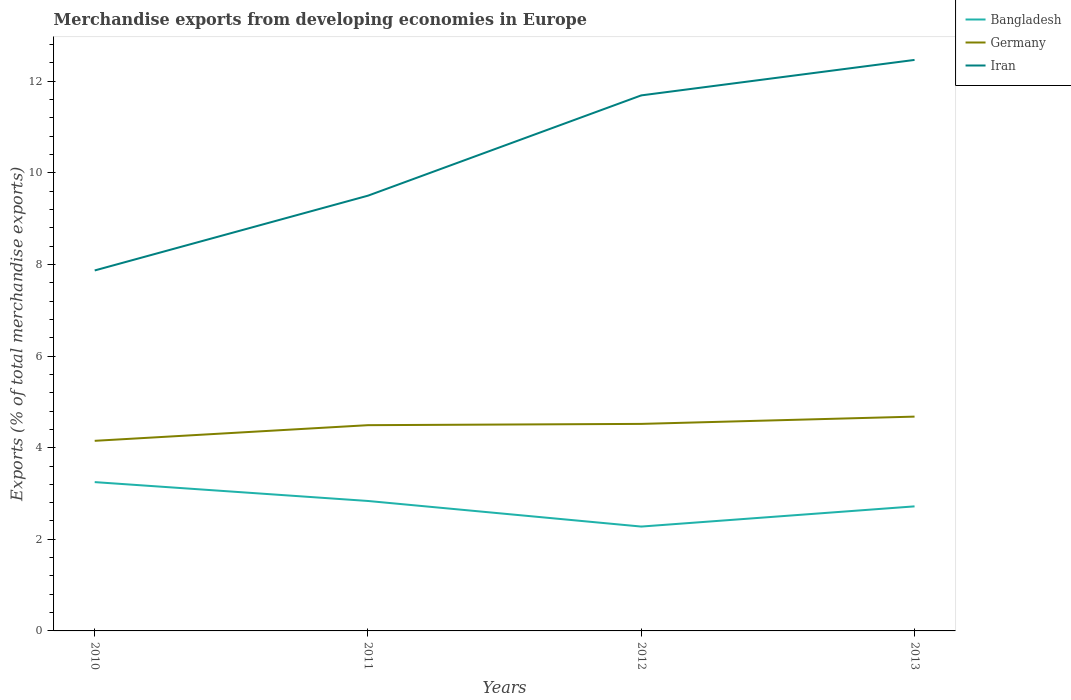Does the line corresponding to Iran intersect with the line corresponding to Bangladesh?
Offer a very short reply. No. Is the number of lines equal to the number of legend labels?
Offer a very short reply. Yes. Across all years, what is the maximum percentage of total merchandise exports in Germany?
Your answer should be compact. 4.15. In which year was the percentage of total merchandise exports in Bangladesh maximum?
Give a very brief answer. 2012. What is the total percentage of total merchandise exports in Iran in the graph?
Your answer should be compact. -0.77. What is the difference between the highest and the second highest percentage of total merchandise exports in Iran?
Give a very brief answer. 4.6. What is the difference between the highest and the lowest percentage of total merchandise exports in Bangladesh?
Provide a succinct answer. 2. Is the percentage of total merchandise exports in Bangladesh strictly greater than the percentage of total merchandise exports in Iran over the years?
Ensure brevity in your answer.  Yes. How many lines are there?
Offer a very short reply. 3. Does the graph contain any zero values?
Provide a succinct answer. No. Where does the legend appear in the graph?
Your answer should be compact. Top right. How many legend labels are there?
Provide a short and direct response. 3. What is the title of the graph?
Your answer should be very brief. Merchandise exports from developing economies in Europe. What is the label or title of the X-axis?
Give a very brief answer. Years. What is the label or title of the Y-axis?
Your response must be concise. Exports (% of total merchandise exports). What is the Exports (% of total merchandise exports) of Bangladesh in 2010?
Make the answer very short. 3.25. What is the Exports (% of total merchandise exports) of Germany in 2010?
Ensure brevity in your answer.  4.15. What is the Exports (% of total merchandise exports) of Iran in 2010?
Your answer should be compact. 7.87. What is the Exports (% of total merchandise exports) of Bangladesh in 2011?
Ensure brevity in your answer.  2.84. What is the Exports (% of total merchandise exports) of Germany in 2011?
Offer a terse response. 4.49. What is the Exports (% of total merchandise exports) of Iran in 2011?
Provide a succinct answer. 9.5. What is the Exports (% of total merchandise exports) of Bangladesh in 2012?
Offer a terse response. 2.28. What is the Exports (% of total merchandise exports) of Germany in 2012?
Offer a very short reply. 4.52. What is the Exports (% of total merchandise exports) in Iran in 2012?
Offer a very short reply. 11.69. What is the Exports (% of total merchandise exports) in Bangladesh in 2013?
Keep it short and to the point. 2.72. What is the Exports (% of total merchandise exports) in Germany in 2013?
Your answer should be compact. 4.68. What is the Exports (% of total merchandise exports) of Iran in 2013?
Provide a succinct answer. 12.47. Across all years, what is the maximum Exports (% of total merchandise exports) of Bangladesh?
Ensure brevity in your answer.  3.25. Across all years, what is the maximum Exports (% of total merchandise exports) of Germany?
Provide a succinct answer. 4.68. Across all years, what is the maximum Exports (% of total merchandise exports) of Iran?
Provide a succinct answer. 12.47. Across all years, what is the minimum Exports (% of total merchandise exports) in Bangladesh?
Provide a succinct answer. 2.28. Across all years, what is the minimum Exports (% of total merchandise exports) in Germany?
Keep it short and to the point. 4.15. Across all years, what is the minimum Exports (% of total merchandise exports) in Iran?
Provide a short and direct response. 7.87. What is the total Exports (% of total merchandise exports) in Bangladesh in the graph?
Make the answer very short. 11.08. What is the total Exports (% of total merchandise exports) of Germany in the graph?
Ensure brevity in your answer.  17.84. What is the total Exports (% of total merchandise exports) of Iran in the graph?
Your answer should be very brief. 41.53. What is the difference between the Exports (% of total merchandise exports) of Bangladesh in 2010 and that in 2011?
Your response must be concise. 0.41. What is the difference between the Exports (% of total merchandise exports) of Germany in 2010 and that in 2011?
Ensure brevity in your answer.  -0.34. What is the difference between the Exports (% of total merchandise exports) in Iran in 2010 and that in 2011?
Offer a terse response. -1.63. What is the difference between the Exports (% of total merchandise exports) of Bangladesh in 2010 and that in 2012?
Keep it short and to the point. 0.97. What is the difference between the Exports (% of total merchandise exports) of Germany in 2010 and that in 2012?
Provide a succinct answer. -0.37. What is the difference between the Exports (% of total merchandise exports) of Iran in 2010 and that in 2012?
Provide a short and direct response. -3.82. What is the difference between the Exports (% of total merchandise exports) in Bangladesh in 2010 and that in 2013?
Your response must be concise. 0.53. What is the difference between the Exports (% of total merchandise exports) of Germany in 2010 and that in 2013?
Your answer should be very brief. -0.53. What is the difference between the Exports (% of total merchandise exports) of Iran in 2010 and that in 2013?
Provide a succinct answer. -4.6. What is the difference between the Exports (% of total merchandise exports) in Bangladesh in 2011 and that in 2012?
Ensure brevity in your answer.  0.56. What is the difference between the Exports (% of total merchandise exports) in Germany in 2011 and that in 2012?
Offer a terse response. -0.03. What is the difference between the Exports (% of total merchandise exports) in Iran in 2011 and that in 2012?
Offer a very short reply. -2.19. What is the difference between the Exports (% of total merchandise exports) in Bangladesh in 2011 and that in 2013?
Make the answer very short. 0.12. What is the difference between the Exports (% of total merchandise exports) of Germany in 2011 and that in 2013?
Provide a succinct answer. -0.19. What is the difference between the Exports (% of total merchandise exports) of Iran in 2011 and that in 2013?
Your answer should be compact. -2.96. What is the difference between the Exports (% of total merchandise exports) in Bangladesh in 2012 and that in 2013?
Keep it short and to the point. -0.44. What is the difference between the Exports (% of total merchandise exports) in Germany in 2012 and that in 2013?
Offer a very short reply. -0.16. What is the difference between the Exports (% of total merchandise exports) of Iran in 2012 and that in 2013?
Make the answer very short. -0.77. What is the difference between the Exports (% of total merchandise exports) in Bangladesh in 2010 and the Exports (% of total merchandise exports) in Germany in 2011?
Give a very brief answer. -1.24. What is the difference between the Exports (% of total merchandise exports) of Bangladesh in 2010 and the Exports (% of total merchandise exports) of Iran in 2011?
Provide a succinct answer. -6.25. What is the difference between the Exports (% of total merchandise exports) in Germany in 2010 and the Exports (% of total merchandise exports) in Iran in 2011?
Provide a succinct answer. -5.35. What is the difference between the Exports (% of total merchandise exports) in Bangladesh in 2010 and the Exports (% of total merchandise exports) in Germany in 2012?
Your response must be concise. -1.27. What is the difference between the Exports (% of total merchandise exports) of Bangladesh in 2010 and the Exports (% of total merchandise exports) of Iran in 2012?
Your answer should be very brief. -8.44. What is the difference between the Exports (% of total merchandise exports) in Germany in 2010 and the Exports (% of total merchandise exports) in Iran in 2012?
Provide a succinct answer. -7.54. What is the difference between the Exports (% of total merchandise exports) of Bangladesh in 2010 and the Exports (% of total merchandise exports) of Germany in 2013?
Ensure brevity in your answer.  -1.43. What is the difference between the Exports (% of total merchandise exports) in Bangladesh in 2010 and the Exports (% of total merchandise exports) in Iran in 2013?
Give a very brief answer. -9.22. What is the difference between the Exports (% of total merchandise exports) in Germany in 2010 and the Exports (% of total merchandise exports) in Iran in 2013?
Make the answer very short. -8.32. What is the difference between the Exports (% of total merchandise exports) of Bangladesh in 2011 and the Exports (% of total merchandise exports) of Germany in 2012?
Offer a terse response. -1.68. What is the difference between the Exports (% of total merchandise exports) in Bangladesh in 2011 and the Exports (% of total merchandise exports) in Iran in 2012?
Your response must be concise. -8.85. What is the difference between the Exports (% of total merchandise exports) of Germany in 2011 and the Exports (% of total merchandise exports) of Iran in 2012?
Ensure brevity in your answer.  -7.2. What is the difference between the Exports (% of total merchandise exports) of Bangladesh in 2011 and the Exports (% of total merchandise exports) of Germany in 2013?
Keep it short and to the point. -1.84. What is the difference between the Exports (% of total merchandise exports) of Bangladesh in 2011 and the Exports (% of total merchandise exports) of Iran in 2013?
Ensure brevity in your answer.  -9.63. What is the difference between the Exports (% of total merchandise exports) in Germany in 2011 and the Exports (% of total merchandise exports) in Iran in 2013?
Your response must be concise. -7.97. What is the difference between the Exports (% of total merchandise exports) of Bangladesh in 2012 and the Exports (% of total merchandise exports) of Germany in 2013?
Ensure brevity in your answer.  -2.4. What is the difference between the Exports (% of total merchandise exports) of Bangladesh in 2012 and the Exports (% of total merchandise exports) of Iran in 2013?
Offer a very short reply. -10.19. What is the difference between the Exports (% of total merchandise exports) of Germany in 2012 and the Exports (% of total merchandise exports) of Iran in 2013?
Offer a terse response. -7.95. What is the average Exports (% of total merchandise exports) in Bangladesh per year?
Ensure brevity in your answer.  2.77. What is the average Exports (% of total merchandise exports) in Germany per year?
Your answer should be very brief. 4.46. What is the average Exports (% of total merchandise exports) of Iran per year?
Ensure brevity in your answer.  10.38. In the year 2010, what is the difference between the Exports (% of total merchandise exports) of Bangladesh and Exports (% of total merchandise exports) of Germany?
Offer a very short reply. -0.9. In the year 2010, what is the difference between the Exports (% of total merchandise exports) in Bangladesh and Exports (% of total merchandise exports) in Iran?
Your answer should be very brief. -4.62. In the year 2010, what is the difference between the Exports (% of total merchandise exports) in Germany and Exports (% of total merchandise exports) in Iran?
Ensure brevity in your answer.  -3.72. In the year 2011, what is the difference between the Exports (% of total merchandise exports) of Bangladesh and Exports (% of total merchandise exports) of Germany?
Give a very brief answer. -1.65. In the year 2011, what is the difference between the Exports (% of total merchandise exports) in Bangladesh and Exports (% of total merchandise exports) in Iran?
Offer a terse response. -6.66. In the year 2011, what is the difference between the Exports (% of total merchandise exports) of Germany and Exports (% of total merchandise exports) of Iran?
Your answer should be very brief. -5.01. In the year 2012, what is the difference between the Exports (% of total merchandise exports) in Bangladesh and Exports (% of total merchandise exports) in Germany?
Keep it short and to the point. -2.24. In the year 2012, what is the difference between the Exports (% of total merchandise exports) in Bangladesh and Exports (% of total merchandise exports) in Iran?
Your answer should be compact. -9.41. In the year 2012, what is the difference between the Exports (% of total merchandise exports) of Germany and Exports (% of total merchandise exports) of Iran?
Offer a very short reply. -7.17. In the year 2013, what is the difference between the Exports (% of total merchandise exports) of Bangladesh and Exports (% of total merchandise exports) of Germany?
Your answer should be compact. -1.96. In the year 2013, what is the difference between the Exports (% of total merchandise exports) of Bangladesh and Exports (% of total merchandise exports) of Iran?
Your answer should be compact. -9.75. In the year 2013, what is the difference between the Exports (% of total merchandise exports) of Germany and Exports (% of total merchandise exports) of Iran?
Give a very brief answer. -7.79. What is the ratio of the Exports (% of total merchandise exports) in Bangladesh in 2010 to that in 2011?
Provide a succinct answer. 1.15. What is the ratio of the Exports (% of total merchandise exports) of Germany in 2010 to that in 2011?
Keep it short and to the point. 0.92. What is the ratio of the Exports (% of total merchandise exports) of Iran in 2010 to that in 2011?
Ensure brevity in your answer.  0.83. What is the ratio of the Exports (% of total merchandise exports) in Bangladesh in 2010 to that in 2012?
Give a very brief answer. 1.43. What is the ratio of the Exports (% of total merchandise exports) of Germany in 2010 to that in 2012?
Ensure brevity in your answer.  0.92. What is the ratio of the Exports (% of total merchandise exports) in Iran in 2010 to that in 2012?
Provide a short and direct response. 0.67. What is the ratio of the Exports (% of total merchandise exports) in Bangladesh in 2010 to that in 2013?
Give a very brief answer. 1.19. What is the ratio of the Exports (% of total merchandise exports) in Germany in 2010 to that in 2013?
Offer a terse response. 0.89. What is the ratio of the Exports (% of total merchandise exports) of Iran in 2010 to that in 2013?
Provide a short and direct response. 0.63. What is the ratio of the Exports (% of total merchandise exports) in Bangladesh in 2011 to that in 2012?
Your response must be concise. 1.25. What is the ratio of the Exports (% of total merchandise exports) in Germany in 2011 to that in 2012?
Ensure brevity in your answer.  0.99. What is the ratio of the Exports (% of total merchandise exports) in Iran in 2011 to that in 2012?
Offer a very short reply. 0.81. What is the ratio of the Exports (% of total merchandise exports) of Bangladesh in 2011 to that in 2013?
Offer a terse response. 1.04. What is the ratio of the Exports (% of total merchandise exports) in Germany in 2011 to that in 2013?
Provide a succinct answer. 0.96. What is the ratio of the Exports (% of total merchandise exports) in Iran in 2011 to that in 2013?
Keep it short and to the point. 0.76. What is the ratio of the Exports (% of total merchandise exports) in Bangladesh in 2012 to that in 2013?
Provide a succinct answer. 0.84. What is the ratio of the Exports (% of total merchandise exports) in Germany in 2012 to that in 2013?
Your answer should be very brief. 0.97. What is the ratio of the Exports (% of total merchandise exports) in Iran in 2012 to that in 2013?
Make the answer very short. 0.94. What is the difference between the highest and the second highest Exports (% of total merchandise exports) in Bangladesh?
Offer a very short reply. 0.41. What is the difference between the highest and the second highest Exports (% of total merchandise exports) in Germany?
Your response must be concise. 0.16. What is the difference between the highest and the second highest Exports (% of total merchandise exports) in Iran?
Your response must be concise. 0.77. What is the difference between the highest and the lowest Exports (% of total merchandise exports) of Bangladesh?
Provide a succinct answer. 0.97. What is the difference between the highest and the lowest Exports (% of total merchandise exports) of Germany?
Keep it short and to the point. 0.53. What is the difference between the highest and the lowest Exports (% of total merchandise exports) in Iran?
Offer a very short reply. 4.6. 